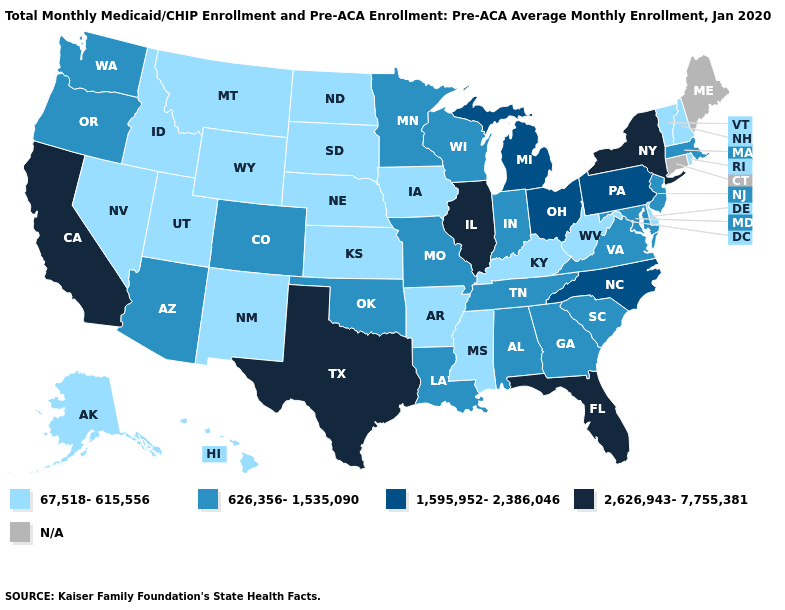What is the value of Alaska?
Answer briefly. 67,518-615,556. What is the highest value in states that border Kentucky?
Write a very short answer. 2,626,943-7,755,381. Does the map have missing data?
Keep it brief. Yes. Name the states that have a value in the range 67,518-615,556?
Be succinct. Alaska, Arkansas, Delaware, Hawaii, Idaho, Iowa, Kansas, Kentucky, Mississippi, Montana, Nebraska, Nevada, New Hampshire, New Mexico, North Dakota, Rhode Island, South Dakota, Utah, Vermont, West Virginia, Wyoming. Name the states that have a value in the range 626,356-1,535,090?
Short answer required. Alabama, Arizona, Colorado, Georgia, Indiana, Louisiana, Maryland, Massachusetts, Minnesota, Missouri, New Jersey, Oklahoma, Oregon, South Carolina, Tennessee, Virginia, Washington, Wisconsin. Name the states that have a value in the range N/A?
Give a very brief answer. Connecticut, Maine. What is the highest value in the MidWest ?
Quick response, please. 2,626,943-7,755,381. How many symbols are there in the legend?
Answer briefly. 5. Name the states that have a value in the range 2,626,943-7,755,381?
Short answer required. California, Florida, Illinois, New York, Texas. Name the states that have a value in the range 1,595,952-2,386,046?
Concise answer only. Michigan, North Carolina, Ohio, Pennsylvania. Name the states that have a value in the range 626,356-1,535,090?
Concise answer only. Alabama, Arizona, Colorado, Georgia, Indiana, Louisiana, Maryland, Massachusetts, Minnesota, Missouri, New Jersey, Oklahoma, Oregon, South Carolina, Tennessee, Virginia, Washington, Wisconsin. What is the value of Louisiana?
Keep it brief. 626,356-1,535,090. What is the highest value in states that border California?
Answer briefly. 626,356-1,535,090. Name the states that have a value in the range 2,626,943-7,755,381?
Give a very brief answer. California, Florida, Illinois, New York, Texas. Name the states that have a value in the range N/A?
Be succinct. Connecticut, Maine. 